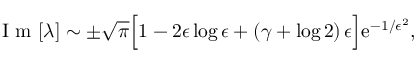<formula> <loc_0><loc_0><loc_500><loc_500>I m [ \lambda ] \sim \pm \sqrt { \pi } \left [ 1 - 2 \epsilon \log \epsilon + \left ( \gamma + \log 2 \right ) \epsilon \right ] e ^ { - 1 / \epsilon ^ { 2 } } ,</formula> 